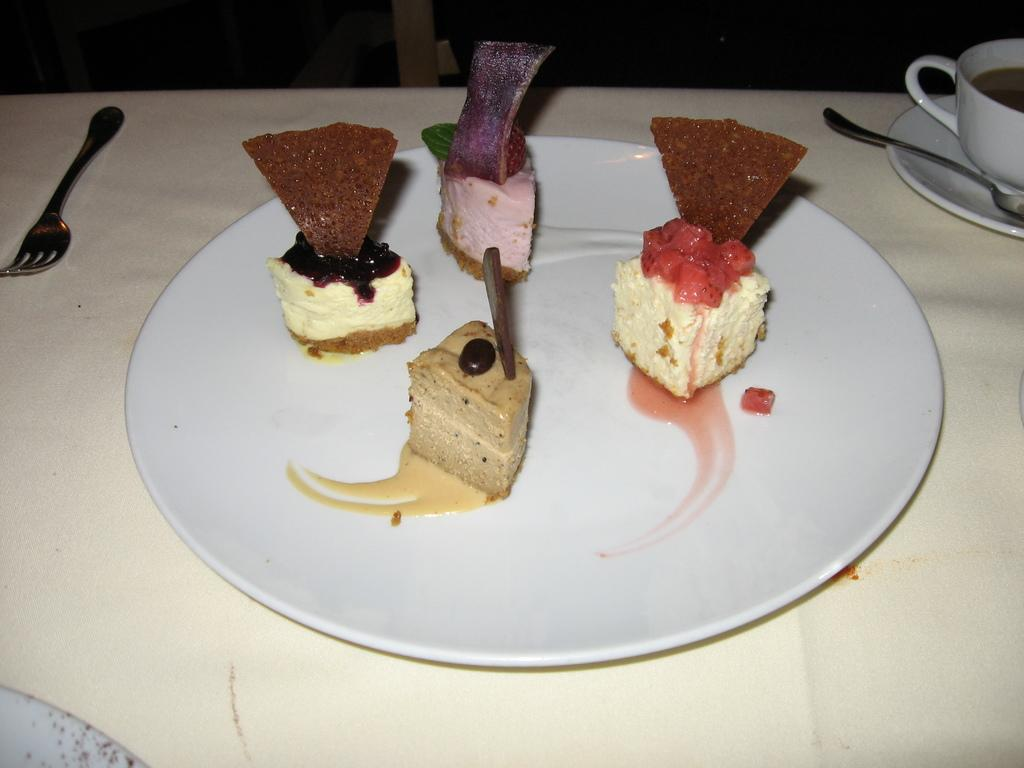What type of furniture is present in the image? There is a table in the image. What food items can be seen on the table? There are different flavors of cakes on the plate. What utensil is placed beside the plate? There is a spoon beside the plate. What beverage container is placed beside the plate? There is a coffee cup beside the plate. What type of prison can be seen in the image? There is no prison present in the image. Is there a veil covering any of the food items in the image? No, there is no veil covering any of the food items in the image. 